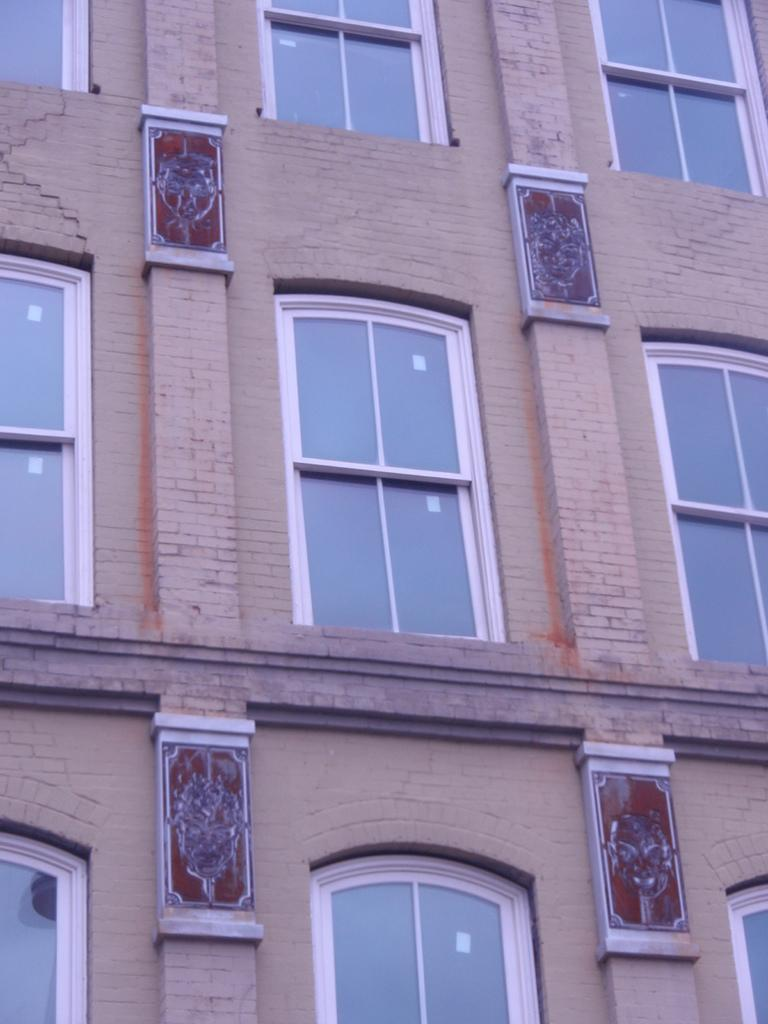What type of structure is present in the image? There is a building in the image. What feature can be observed on the building? The building has glass windows. How many frogs can be seen breathing inside the building in the image? There are no frogs present in the image, and therefore no such activity can be observed. 